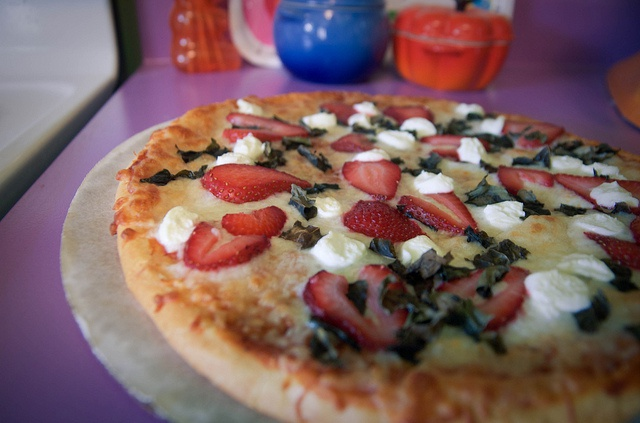Describe the objects in this image and their specific colors. I can see a pizza in gray, maroon, black, and brown tones in this image. 